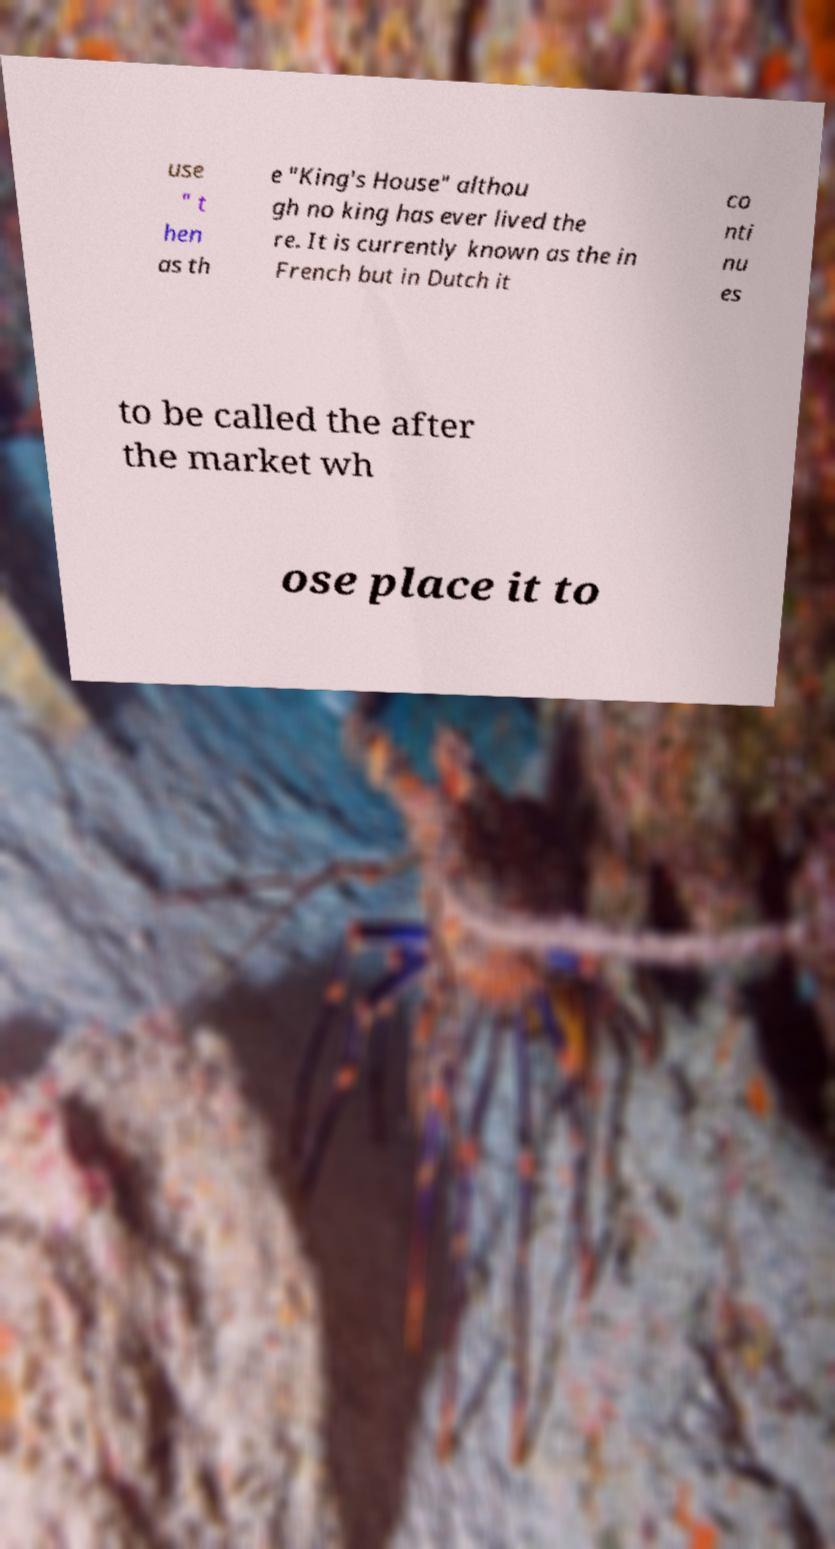Could you extract and type out the text from this image? use " t hen as th e "King's House" althou gh no king has ever lived the re. It is currently known as the in French but in Dutch it co nti nu es to be called the after the market wh ose place it to 